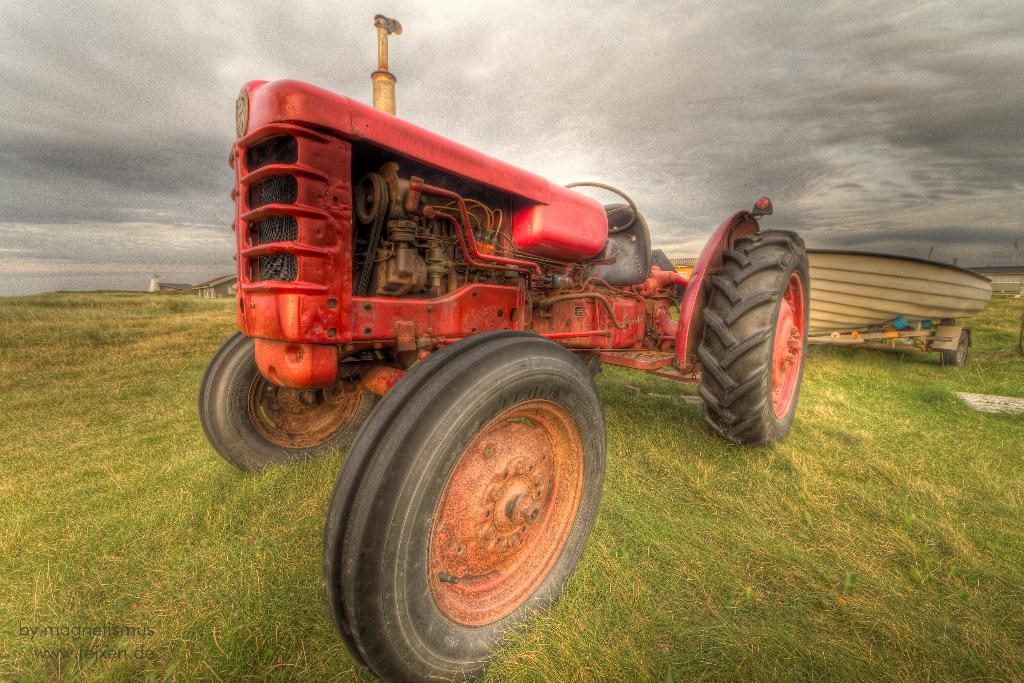What is the main subject of the image? The main subject of the image is a tractor. Where is the tractor located? The tractor is parked on the grass. What can be seen in the distance in the image? There is a compartment in the distance. What is visible in the background of the image? The sky is visible in the background of the image. What story is the tractor telling in the image? The tractor is not telling a story in the image; it is simply parked on the grass. How many eyes does the tractor have in the image? Tractors do not have eyes, so this question cannot be answered. 